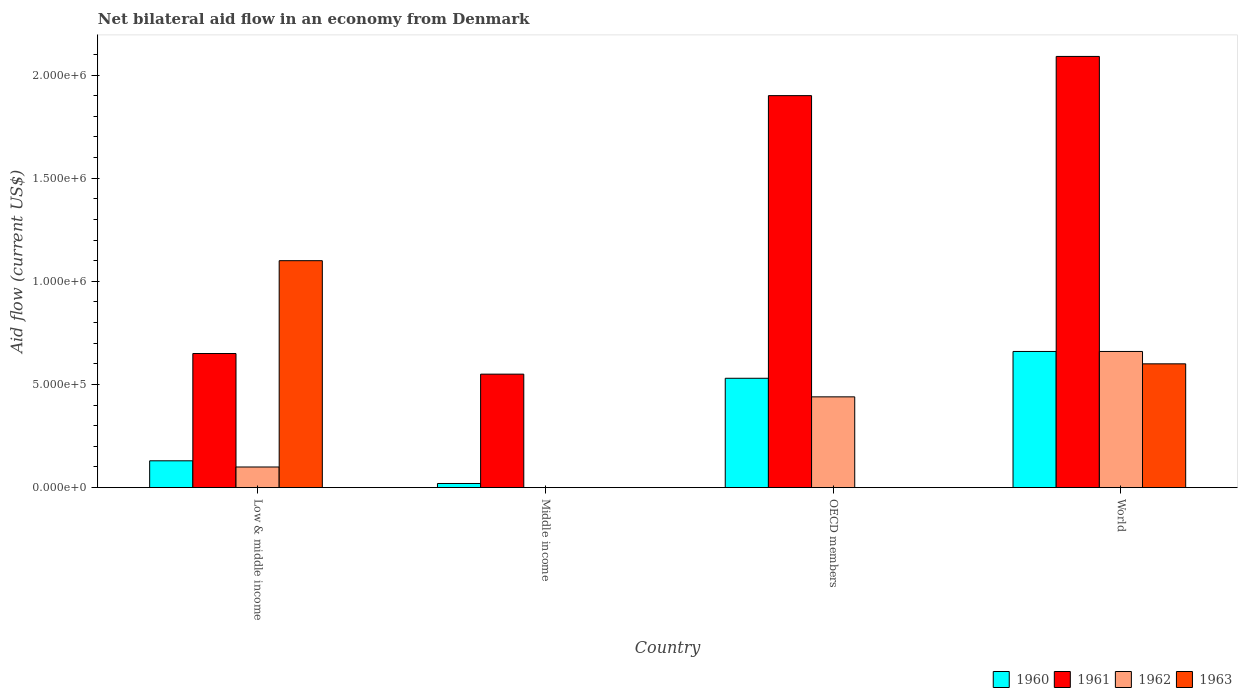How many different coloured bars are there?
Offer a very short reply. 4. How many groups of bars are there?
Offer a very short reply. 4. Are the number of bars on each tick of the X-axis equal?
Your answer should be very brief. No. How many bars are there on the 1st tick from the left?
Offer a very short reply. 4. How many bars are there on the 2nd tick from the right?
Provide a short and direct response. 3. In how many cases, is the number of bars for a given country not equal to the number of legend labels?
Your answer should be very brief. 2. What is the net bilateral aid flow in 1963 in OECD members?
Provide a succinct answer. 0. Across all countries, what is the maximum net bilateral aid flow in 1961?
Keep it short and to the point. 2.09e+06. Across all countries, what is the minimum net bilateral aid flow in 1963?
Give a very brief answer. 0. What is the total net bilateral aid flow in 1962 in the graph?
Your response must be concise. 1.20e+06. What is the difference between the net bilateral aid flow in 1961 in Low & middle income and that in World?
Make the answer very short. -1.44e+06. What is the difference between the net bilateral aid flow in 1962 in Middle income and the net bilateral aid flow in 1961 in Low & middle income?
Your answer should be very brief. -6.50e+05. What is the average net bilateral aid flow in 1963 per country?
Give a very brief answer. 4.25e+05. What is the difference between the net bilateral aid flow of/in 1962 and net bilateral aid flow of/in 1963 in Low & middle income?
Your response must be concise. -1.00e+06. What is the ratio of the net bilateral aid flow in 1962 in Low & middle income to that in World?
Provide a short and direct response. 0.15. What is the difference between the highest and the second highest net bilateral aid flow in 1960?
Give a very brief answer. 1.30e+05. What is the difference between the highest and the lowest net bilateral aid flow in 1960?
Provide a short and direct response. 6.40e+05. Is it the case that in every country, the sum of the net bilateral aid flow in 1960 and net bilateral aid flow in 1961 is greater than the sum of net bilateral aid flow in 1962 and net bilateral aid flow in 1963?
Your answer should be compact. No. Is it the case that in every country, the sum of the net bilateral aid flow in 1962 and net bilateral aid flow in 1960 is greater than the net bilateral aid flow in 1961?
Give a very brief answer. No. How many countries are there in the graph?
Give a very brief answer. 4. What is the difference between two consecutive major ticks on the Y-axis?
Provide a short and direct response. 5.00e+05. Are the values on the major ticks of Y-axis written in scientific E-notation?
Your response must be concise. Yes. Does the graph contain any zero values?
Provide a succinct answer. Yes. Where does the legend appear in the graph?
Your answer should be compact. Bottom right. How are the legend labels stacked?
Your answer should be very brief. Horizontal. What is the title of the graph?
Your response must be concise. Net bilateral aid flow in an economy from Denmark. Does "1981" appear as one of the legend labels in the graph?
Your answer should be very brief. No. What is the label or title of the X-axis?
Provide a succinct answer. Country. What is the label or title of the Y-axis?
Make the answer very short. Aid flow (current US$). What is the Aid flow (current US$) of 1961 in Low & middle income?
Make the answer very short. 6.50e+05. What is the Aid flow (current US$) in 1963 in Low & middle income?
Keep it short and to the point. 1.10e+06. What is the Aid flow (current US$) of 1960 in Middle income?
Provide a short and direct response. 2.00e+04. What is the Aid flow (current US$) of 1960 in OECD members?
Ensure brevity in your answer.  5.30e+05. What is the Aid flow (current US$) of 1961 in OECD members?
Your answer should be very brief. 1.90e+06. What is the Aid flow (current US$) of 1962 in OECD members?
Your answer should be very brief. 4.40e+05. What is the Aid flow (current US$) of 1963 in OECD members?
Offer a very short reply. 0. What is the Aid flow (current US$) in 1960 in World?
Ensure brevity in your answer.  6.60e+05. What is the Aid flow (current US$) of 1961 in World?
Provide a short and direct response. 2.09e+06. What is the Aid flow (current US$) in 1962 in World?
Offer a very short reply. 6.60e+05. Across all countries, what is the maximum Aid flow (current US$) in 1961?
Ensure brevity in your answer.  2.09e+06. Across all countries, what is the maximum Aid flow (current US$) of 1963?
Make the answer very short. 1.10e+06. Across all countries, what is the minimum Aid flow (current US$) of 1960?
Provide a short and direct response. 2.00e+04. Across all countries, what is the minimum Aid flow (current US$) in 1962?
Make the answer very short. 0. Across all countries, what is the minimum Aid flow (current US$) of 1963?
Offer a very short reply. 0. What is the total Aid flow (current US$) of 1960 in the graph?
Make the answer very short. 1.34e+06. What is the total Aid flow (current US$) of 1961 in the graph?
Your response must be concise. 5.19e+06. What is the total Aid flow (current US$) of 1962 in the graph?
Your answer should be compact. 1.20e+06. What is the total Aid flow (current US$) in 1963 in the graph?
Offer a very short reply. 1.70e+06. What is the difference between the Aid flow (current US$) in 1960 in Low & middle income and that in Middle income?
Provide a succinct answer. 1.10e+05. What is the difference between the Aid flow (current US$) of 1960 in Low & middle income and that in OECD members?
Give a very brief answer. -4.00e+05. What is the difference between the Aid flow (current US$) of 1961 in Low & middle income and that in OECD members?
Provide a succinct answer. -1.25e+06. What is the difference between the Aid flow (current US$) in 1960 in Low & middle income and that in World?
Offer a very short reply. -5.30e+05. What is the difference between the Aid flow (current US$) of 1961 in Low & middle income and that in World?
Your answer should be very brief. -1.44e+06. What is the difference between the Aid flow (current US$) in 1962 in Low & middle income and that in World?
Give a very brief answer. -5.60e+05. What is the difference between the Aid flow (current US$) in 1960 in Middle income and that in OECD members?
Ensure brevity in your answer.  -5.10e+05. What is the difference between the Aid flow (current US$) of 1961 in Middle income and that in OECD members?
Offer a very short reply. -1.35e+06. What is the difference between the Aid flow (current US$) of 1960 in Middle income and that in World?
Your response must be concise. -6.40e+05. What is the difference between the Aid flow (current US$) in 1961 in Middle income and that in World?
Offer a very short reply. -1.54e+06. What is the difference between the Aid flow (current US$) in 1960 in OECD members and that in World?
Give a very brief answer. -1.30e+05. What is the difference between the Aid flow (current US$) in 1962 in OECD members and that in World?
Your answer should be very brief. -2.20e+05. What is the difference between the Aid flow (current US$) in 1960 in Low & middle income and the Aid flow (current US$) in 1961 in Middle income?
Keep it short and to the point. -4.20e+05. What is the difference between the Aid flow (current US$) of 1960 in Low & middle income and the Aid flow (current US$) of 1961 in OECD members?
Offer a terse response. -1.77e+06. What is the difference between the Aid flow (current US$) of 1960 in Low & middle income and the Aid flow (current US$) of 1962 in OECD members?
Give a very brief answer. -3.10e+05. What is the difference between the Aid flow (current US$) in 1961 in Low & middle income and the Aid flow (current US$) in 1962 in OECD members?
Ensure brevity in your answer.  2.10e+05. What is the difference between the Aid flow (current US$) in 1960 in Low & middle income and the Aid flow (current US$) in 1961 in World?
Give a very brief answer. -1.96e+06. What is the difference between the Aid flow (current US$) of 1960 in Low & middle income and the Aid flow (current US$) of 1962 in World?
Offer a terse response. -5.30e+05. What is the difference between the Aid flow (current US$) of 1960 in Low & middle income and the Aid flow (current US$) of 1963 in World?
Make the answer very short. -4.70e+05. What is the difference between the Aid flow (current US$) of 1961 in Low & middle income and the Aid flow (current US$) of 1962 in World?
Offer a very short reply. -10000. What is the difference between the Aid flow (current US$) in 1962 in Low & middle income and the Aid flow (current US$) in 1963 in World?
Offer a very short reply. -5.00e+05. What is the difference between the Aid flow (current US$) in 1960 in Middle income and the Aid flow (current US$) in 1961 in OECD members?
Your response must be concise. -1.88e+06. What is the difference between the Aid flow (current US$) of 1960 in Middle income and the Aid flow (current US$) of 1962 in OECD members?
Offer a terse response. -4.20e+05. What is the difference between the Aid flow (current US$) in 1961 in Middle income and the Aid flow (current US$) in 1962 in OECD members?
Offer a very short reply. 1.10e+05. What is the difference between the Aid flow (current US$) in 1960 in Middle income and the Aid flow (current US$) in 1961 in World?
Ensure brevity in your answer.  -2.07e+06. What is the difference between the Aid flow (current US$) in 1960 in Middle income and the Aid flow (current US$) in 1962 in World?
Your answer should be compact. -6.40e+05. What is the difference between the Aid flow (current US$) in 1960 in Middle income and the Aid flow (current US$) in 1963 in World?
Offer a very short reply. -5.80e+05. What is the difference between the Aid flow (current US$) in 1961 in Middle income and the Aid flow (current US$) in 1962 in World?
Offer a very short reply. -1.10e+05. What is the difference between the Aid flow (current US$) in 1961 in Middle income and the Aid flow (current US$) in 1963 in World?
Provide a short and direct response. -5.00e+04. What is the difference between the Aid flow (current US$) in 1960 in OECD members and the Aid flow (current US$) in 1961 in World?
Provide a succinct answer. -1.56e+06. What is the difference between the Aid flow (current US$) of 1960 in OECD members and the Aid flow (current US$) of 1962 in World?
Your answer should be very brief. -1.30e+05. What is the difference between the Aid flow (current US$) of 1961 in OECD members and the Aid flow (current US$) of 1962 in World?
Provide a short and direct response. 1.24e+06. What is the difference between the Aid flow (current US$) in 1961 in OECD members and the Aid flow (current US$) in 1963 in World?
Provide a succinct answer. 1.30e+06. What is the average Aid flow (current US$) in 1960 per country?
Provide a short and direct response. 3.35e+05. What is the average Aid flow (current US$) in 1961 per country?
Offer a terse response. 1.30e+06. What is the average Aid flow (current US$) of 1963 per country?
Make the answer very short. 4.25e+05. What is the difference between the Aid flow (current US$) in 1960 and Aid flow (current US$) in 1961 in Low & middle income?
Your response must be concise. -5.20e+05. What is the difference between the Aid flow (current US$) in 1960 and Aid flow (current US$) in 1963 in Low & middle income?
Provide a succinct answer. -9.70e+05. What is the difference between the Aid flow (current US$) in 1961 and Aid flow (current US$) in 1962 in Low & middle income?
Provide a short and direct response. 5.50e+05. What is the difference between the Aid flow (current US$) of 1961 and Aid flow (current US$) of 1963 in Low & middle income?
Make the answer very short. -4.50e+05. What is the difference between the Aid flow (current US$) of 1962 and Aid flow (current US$) of 1963 in Low & middle income?
Offer a very short reply. -1.00e+06. What is the difference between the Aid flow (current US$) in 1960 and Aid flow (current US$) in 1961 in Middle income?
Provide a short and direct response. -5.30e+05. What is the difference between the Aid flow (current US$) in 1960 and Aid flow (current US$) in 1961 in OECD members?
Your answer should be compact. -1.37e+06. What is the difference between the Aid flow (current US$) in 1960 and Aid flow (current US$) in 1962 in OECD members?
Keep it short and to the point. 9.00e+04. What is the difference between the Aid flow (current US$) in 1961 and Aid flow (current US$) in 1962 in OECD members?
Your answer should be very brief. 1.46e+06. What is the difference between the Aid flow (current US$) of 1960 and Aid flow (current US$) of 1961 in World?
Provide a succinct answer. -1.43e+06. What is the difference between the Aid flow (current US$) of 1960 and Aid flow (current US$) of 1962 in World?
Your response must be concise. 0. What is the difference between the Aid flow (current US$) in 1961 and Aid flow (current US$) in 1962 in World?
Provide a succinct answer. 1.43e+06. What is the difference between the Aid flow (current US$) of 1961 and Aid flow (current US$) of 1963 in World?
Offer a terse response. 1.49e+06. What is the difference between the Aid flow (current US$) of 1962 and Aid flow (current US$) of 1963 in World?
Ensure brevity in your answer.  6.00e+04. What is the ratio of the Aid flow (current US$) of 1961 in Low & middle income to that in Middle income?
Offer a very short reply. 1.18. What is the ratio of the Aid flow (current US$) of 1960 in Low & middle income to that in OECD members?
Give a very brief answer. 0.25. What is the ratio of the Aid flow (current US$) in 1961 in Low & middle income to that in OECD members?
Give a very brief answer. 0.34. What is the ratio of the Aid flow (current US$) of 1962 in Low & middle income to that in OECD members?
Offer a very short reply. 0.23. What is the ratio of the Aid flow (current US$) of 1960 in Low & middle income to that in World?
Offer a terse response. 0.2. What is the ratio of the Aid flow (current US$) in 1961 in Low & middle income to that in World?
Ensure brevity in your answer.  0.31. What is the ratio of the Aid flow (current US$) in 1962 in Low & middle income to that in World?
Offer a very short reply. 0.15. What is the ratio of the Aid flow (current US$) of 1963 in Low & middle income to that in World?
Provide a succinct answer. 1.83. What is the ratio of the Aid flow (current US$) of 1960 in Middle income to that in OECD members?
Offer a terse response. 0.04. What is the ratio of the Aid flow (current US$) of 1961 in Middle income to that in OECD members?
Provide a succinct answer. 0.29. What is the ratio of the Aid flow (current US$) of 1960 in Middle income to that in World?
Your answer should be very brief. 0.03. What is the ratio of the Aid flow (current US$) of 1961 in Middle income to that in World?
Provide a succinct answer. 0.26. What is the ratio of the Aid flow (current US$) in 1960 in OECD members to that in World?
Your answer should be very brief. 0.8. What is the ratio of the Aid flow (current US$) in 1961 in OECD members to that in World?
Your response must be concise. 0.91. What is the difference between the highest and the second highest Aid flow (current US$) of 1960?
Ensure brevity in your answer.  1.30e+05. What is the difference between the highest and the second highest Aid flow (current US$) in 1961?
Offer a very short reply. 1.90e+05. What is the difference between the highest and the lowest Aid flow (current US$) of 1960?
Keep it short and to the point. 6.40e+05. What is the difference between the highest and the lowest Aid flow (current US$) of 1961?
Provide a short and direct response. 1.54e+06. What is the difference between the highest and the lowest Aid flow (current US$) in 1962?
Make the answer very short. 6.60e+05. What is the difference between the highest and the lowest Aid flow (current US$) of 1963?
Keep it short and to the point. 1.10e+06. 